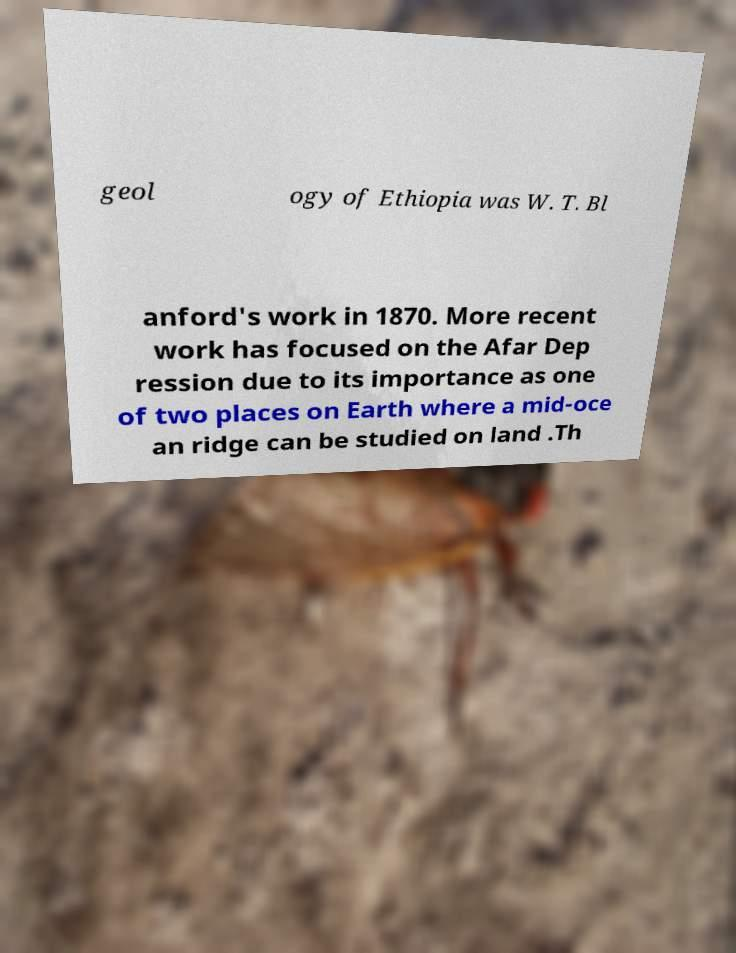Can you accurately transcribe the text from the provided image for me? geol ogy of Ethiopia was W. T. Bl anford's work in 1870. More recent work has focused on the Afar Dep ression due to its importance as one of two places on Earth where a mid-oce an ridge can be studied on land .Th 